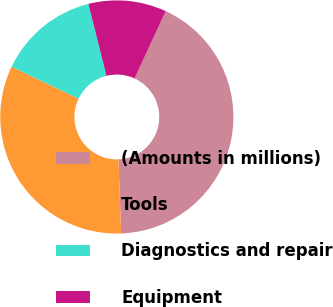Convert chart. <chart><loc_0><loc_0><loc_500><loc_500><pie_chart><fcel>(Amounts in millions)<fcel>Tools<fcel>Diagnostics and repair<fcel>Equipment<nl><fcel>42.53%<fcel>32.69%<fcel>13.98%<fcel>10.81%<nl></chart> 